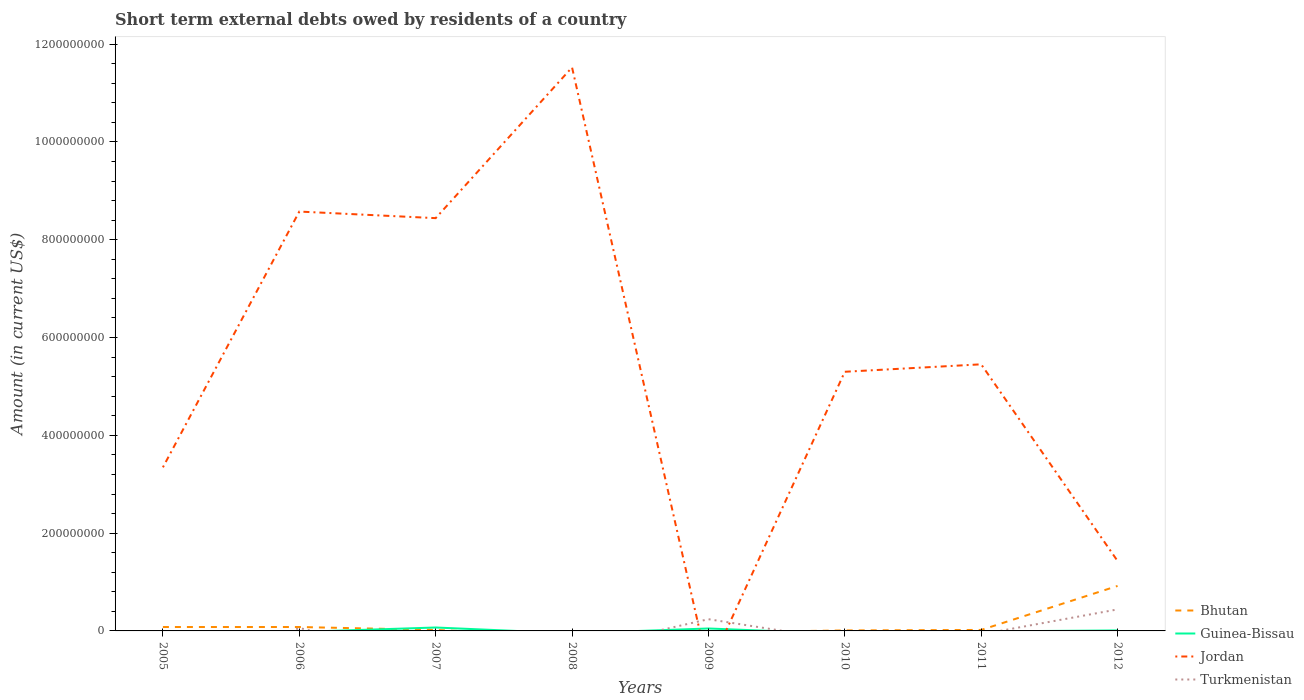How many different coloured lines are there?
Ensure brevity in your answer.  4. Does the line corresponding to Turkmenistan intersect with the line corresponding to Guinea-Bissau?
Give a very brief answer. Yes. What is the total amount of short-term external debts owed by residents in Turkmenistan in the graph?
Offer a very short reply. -1.80e+07. What is the difference between the highest and the second highest amount of short-term external debts owed by residents in Guinea-Bissau?
Make the answer very short. 7.00e+06. Is the amount of short-term external debts owed by residents in Guinea-Bissau strictly greater than the amount of short-term external debts owed by residents in Turkmenistan over the years?
Ensure brevity in your answer.  No. Are the values on the major ticks of Y-axis written in scientific E-notation?
Your answer should be compact. No. How are the legend labels stacked?
Your answer should be compact. Vertical. What is the title of the graph?
Offer a terse response. Short term external debts owed by residents of a country. What is the label or title of the X-axis?
Give a very brief answer. Years. What is the Amount (in current US$) of Bhutan in 2005?
Provide a short and direct response. 8.00e+06. What is the Amount (in current US$) in Jordan in 2005?
Your answer should be very brief. 3.35e+08. What is the Amount (in current US$) of Turkmenistan in 2005?
Provide a succinct answer. 0. What is the Amount (in current US$) of Guinea-Bissau in 2006?
Ensure brevity in your answer.  0. What is the Amount (in current US$) in Jordan in 2006?
Keep it short and to the point. 8.58e+08. What is the Amount (in current US$) of Guinea-Bissau in 2007?
Provide a succinct answer. 7.00e+06. What is the Amount (in current US$) in Jordan in 2007?
Provide a short and direct response. 8.44e+08. What is the Amount (in current US$) of Bhutan in 2008?
Your answer should be compact. 0. What is the Amount (in current US$) of Guinea-Bissau in 2008?
Keep it short and to the point. 0. What is the Amount (in current US$) of Jordan in 2008?
Make the answer very short. 1.15e+09. What is the Amount (in current US$) of Jordan in 2009?
Your answer should be very brief. 0. What is the Amount (in current US$) in Turkmenistan in 2009?
Your answer should be very brief. 2.40e+07. What is the Amount (in current US$) of Guinea-Bissau in 2010?
Your answer should be compact. 0. What is the Amount (in current US$) of Jordan in 2010?
Provide a short and direct response. 5.30e+08. What is the Amount (in current US$) in Turkmenistan in 2010?
Keep it short and to the point. 0. What is the Amount (in current US$) in Bhutan in 2011?
Provide a short and direct response. 2.00e+06. What is the Amount (in current US$) in Jordan in 2011?
Your response must be concise. 5.45e+08. What is the Amount (in current US$) in Turkmenistan in 2011?
Offer a very short reply. 0. What is the Amount (in current US$) of Bhutan in 2012?
Provide a succinct answer. 9.20e+07. What is the Amount (in current US$) in Jordan in 2012?
Provide a succinct answer. 1.43e+08. What is the Amount (in current US$) of Turkmenistan in 2012?
Ensure brevity in your answer.  4.40e+07. Across all years, what is the maximum Amount (in current US$) in Bhutan?
Keep it short and to the point. 9.20e+07. Across all years, what is the maximum Amount (in current US$) of Guinea-Bissau?
Ensure brevity in your answer.  7.00e+06. Across all years, what is the maximum Amount (in current US$) of Jordan?
Offer a very short reply. 1.15e+09. Across all years, what is the maximum Amount (in current US$) in Turkmenistan?
Your response must be concise. 4.40e+07. Across all years, what is the minimum Amount (in current US$) in Bhutan?
Your answer should be very brief. 0. Across all years, what is the minimum Amount (in current US$) of Guinea-Bissau?
Make the answer very short. 0. Across all years, what is the minimum Amount (in current US$) of Turkmenistan?
Keep it short and to the point. 0. What is the total Amount (in current US$) of Bhutan in the graph?
Keep it short and to the point. 1.13e+08. What is the total Amount (in current US$) of Guinea-Bissau in the graph?
Your response must be concise. 1.30e+07. What is the total Amount (in current US$) in Jordan in the graph?
Your answer should be very brief. 4.41e+09. What is the total Amount (in current US$) of Turkmenistan in the graph?
Your answer should be compact. 7.40e+07. What is the difference between the Amount (in current US$) in Jordan in 2005 and that in 2006?
Ensure brevity in your answer.  -5.23e+08. What is the difference between the Amount (in current US$) in Jordan in 2005 and that in 2007?
Your answer should be very brief. -5.10e+08. What is the difference between the Amount (in current US$) of Jordan in 2005 and that in 2008?
Make the answer very short. -8.18e+08. What is the difference between the Amount (in current US$) in Jordan in 2005 and that in 2010?
Give a very brief answer. -1.95e+08. What is the difference between the Amount (in current US$) in Bhutan in 2005 and that in 2011?
Offer a very short reply. 6.00e+06. What is the difference between the Amount (in current US$) in Jordan in 2005 and that in 2011?
Provide a succinct answer. -2.11e+08. What is the difference between the Amount (in current US$) in Bhutan in 2005 and that in 2012?
Your answer should be very brief. -8.40e+07. What is the difference between the Amount (in current US$) of Jordan in 2005 and that in 2012?
Offer a terse response. 1.91e+08. What is the difference between the Amount (in current US$) in Jordan in 2006 and that in 2007?
Ensure brevity in your answer.  1.35e+07. What is the difference between the Amount (in current US$) of Jordan in 2006 and that in 2008?
Provide a short and direct response. -2.95e+08. What is the difference between the Amount (in current US$) of Turkmenistan in 2006 and that in 2009?
Keep it short and to the point. -1.80e+07. What is the difference between the Amount (in current US$) in Jordan in 2006 and that in 2010?
Ensure brevity in your answer.  3.28e+08. What is the difference between the Amount (in current US$) in Bhutan in 2006 and that in 2011?
Offer a very short reply. 6.00e+06. What is the difference between the Amount (in current US$) of Jordan in 2006 and that in 2011?
Provide a succinct answer. 3.12e+08. What is the difference between the Amount (in current US$) of Bhutan in 2006 and that in 2012?
Your answer should be compact. -8.40e+07. What is the difference between the Amount (in current US$) in Jordan in 2006 and that in 2012?
Provide a succinct answer. 7.15e+08. What is the difference between the Amount (in current US$) of Turkmenistan in 2006 and that in 2012?
Your answer should be compact. -3.80e+07. What is the difference between the Amount (in current US$) in Jordan in 2007 and that in 2008?
Offer a terse response. -3.08e+08. What is the difference between the Amount (in current US$) in Jordan in 2007 and that in 2010?
Make the answer very short. 3.14e+08. What is the difference between the Amount (in current US$) of Bhutan in 2007 and that in 2011?
Ensure brevity in your answer.  0. What is the difference between the Amount (in current US$) of Jordan in 2007 and that in 2011?
Your response must be concise. 2.99e+08. What is the difference between the Amount (in current US$) in Bhutan in 2007 and that in 2012?
Your response must be concise. -9.00e+07. What is the difference between the Amount (in current US$) in Guinea-Bissau in 2007 and that in 2012?
Ensure brevity in your answer.  6.00e+06. What is the difference between the Amount (in current US$) of Jordan in 2007 and that in 2012?
Make the answer very short. 7.01e+08. What is the difference between the Amount (in current US$) in Jordan in 2008 and that in 2010?
Make the answer very short. 6.22e+08. What is the difference between the Amount (in current US$) in Jordan in 2008 and that in 2011?
Ensure brevity in your answer.  6.07e+08. What is the difference between the Amount (in current US$) of Jordan in 2008 and that in 2012?
Provide a short and direct response. 1.01e+09. What is the difference between the Amount (in current US$) in Turkmenistan in 2009 and that in 2012?
Your response must be concise. -2.00e+07. What is the difference between the Amount (in current US$) in Bhutan in 2010 and that in 2011?
Provide a succinct answer. -1.00e+06. What is the difference between the Amount (in current US$) in Jordan in 2010 and that in 2011?
Your answer should be very brief. -1.52e+07. What is the difference between the Amount (in current US$) of Bhutan in 2010 and that in 2012?
Offer a terse response. -9.10e+07. What is the difference between the Amount (in current US$) of Jordan in 2010 and that in 2012?
Provide a short and direct response. 3.87e+08. What is the difference between the Amount (in current US$) of Bhutan in 2011 and that in 2012?
Make the answer very short. -9.00e+07. What is the difference between the Amount (in current US$) in Jordan in 2011 and that in 2012?
Give a very brief answer. 4.02e+08. What is the difference between the Amount (in current US$) in Bhutan in 2005 and the Amount (in current US$) in Jordan in 2006?
Offer a terse response. -8.50e+08. What is the difference between the Amount (in current US$) of Bhutan in 2005 and the Amount (in current US$) of Turkmenistan in 2006?
Your answer should be very brief. 2.00e+06. What is the difference between the Amount (in current US$) in Jordan in 2005 and the Amount (in current US$) in Turkmenistan in 2006?
Make the answer very short. 3.29e+08. What is the difference between the Amount (in current US$) of Bhutan in 2005 and the Amount (in current US$) of Guinea-Bissau in 2007?
Ensure brevity in your answer.  1.00e+06. What is the difference between the Amount (in current US$) in Bhutan in 2005 and the Amount (in current US$) in Jordan in 2007?
Your response must be concise. -8.36e+08. What is the difference between the Amount (in current US$) of Bhutan in 2005 and the Amount (in current US$) of Jordan in 2008?
Provide a succinct answer. -1.14e+09. What is the difference between the Amount (in current US$) in Bhutan in 2005 and the Amount (in current US$) in Guinea-Bissau in 2009?
Your answer should be compact. 3.00e+06. What is the difference between the Amount (in current US$) of Bhutan in 2005 and the Amount (in current US$) of Turkmenistan in 2009?
Make the answer very short. -1.60e+07. What is the difference between the Amount (in current US$) of Jordan in 2005 and the Amount (in current US$) of Turkmenistan in 2009?
Offer a terse response. 3.11e+08. What is the difference between the Amount (in current US$) of Bhutan in 2005 and the Amount (in current US$) of Jordan in 2010?
Your answer should be compact. -5.22e+08. What is the difference between the Amount (in current US$) in Bhutan in 2005 and the Amount (in current US$) in Jordan in 2011?
Your response must be concise. -5.37e+08. What is the difference between the Amount (in current US$) in Bhutan in 2005 and the Amount (in current US$) in Guinea-Bissau in 2012?
Ensure brevity in your answer.  7.00e+06. What is the difference between the Amount (in current US$) in Bhutan in 2005 and the Amount (in current US$) in Jordan in 2012?
Your answer should be compact. -1.35e+08. What is the difference between the Amount (in current US$) of Bhutan in 2005 and the Amount (in current US$) of Turkmenistan in 2012?
Your response must be concise. -3.60e+07. What is the difference between the Amount (in current US$) in Jordan in 2005 and the Amount (in current US$) in Turkmenistan in 2012?
Provide a short and direct response. 2.91e+08. What is the difference between the Amount (in current US$) of Bhutan in 2006 and the Amount (in current US$) of Guinea-Bissau in 2007?
Provide a succinct answer. 1.00e+06. What is the difference between the Amount (in current US$) of Bhutan in 2006 and the Amount (in current US$) of Jordan in 2007?
Your response must be concise. -8.36e+08. What is the difference between the Amount (in current US$) of Bhutan in 2006 and the Amount (in current US$) of Jordan in 2008?
Make the answer very short. -1.14e+09. What is the difference between the Amount (in current US$) in Bhutan in 2006 and the Amount (in current US$) in Guinea-Bissau in 2009?
Offer a very short reply. 3.00e+06. What is the difference between the Amount (in current US$) in Bhutan in 2006 and the Amount (in current US$) in Turkmenistan in 2009?
Give a very brief answer. -1.60e+07. What is the difference between the Amount (in current US$) of Jordan in 2006 and the Amount (in current US$) of Turkmenistan in 2009?
Offer a terse response. 8.34e+08. What is the difference between the Amount (in current US$) of Bhutan in 2006 and the Amount (in current US$) of Jordan in 2010?
Provide a short and direct response. -5.22e+08. What is the difference between the Amount (in current US$) of Bhutan in 2006 and the Amount (in current US$) of Jordan in 2011?
Your answer should be very brief. -5.37e+08. What is the difference between the Amount (in current US$) of Bhutan in 2006 and the Amount (in current US$) of Guinea-Bissau in 2012?
Ensure brevity in your answer.  7.00e+06. What is the difference between the Amount (in current US$) in Bhutan in 2006 and the Amount (in current US$) in Jordan in 2012?
Provide a succinct answer. -1.35e+08. What is the difference between the Amount (in current US$) of Bhutan in 2006 and the Amount (in current US$) of Turkmenistan in 2012?
Offer a terse response. -3.60e+07. What is the difference between the Amount (in current US$) of Jordan in 2006 and the Amount (in current US$) of Turkmenistan in 2012?
Your answer should be very brief. 8.14e+08. What is the difference between the Amount (in current US$) in Bhutan in 2007 and the Amount (in current US$) in Jordan in 2008?
Make the answer very short. -1.15e+09. What is the difference between the Amount (in current US$) of Guinea-Bissau in 2007 and the Amount (in current US$) of Jordan in 2008?
Give a very brief answer. -1.15e+09. What is the difference between the Amount (in current US$) in Bhutan in 2007 and the Amount (in current US$) in Turkmenistan in 2009?
Provide a succinct answer. -2.20e+07. What is the difference between the Amount (in current US$) in Guinea-Bissau in 2007 and the Amount (in current US$) in Turkmenistan in 2009?
Provide a succinct answer. -1.70e+07. What is the difference between the Amount (in current US$) in Jordan in 2007 and the Amount (in current US$) in Turkmenistan in 2009?
Your answer should be very brief. 8.20e+08. What is the difference between the Amount (in current US$) of Bhutan in 2007 and the Amount (in current US$) of Jordan in 2010?
Your answer should be very brief. -5.28e+08. What is the difference between the Amount (in current US$) in Guinea-Bissau in 2007 and the Amount (in current US$) in Jordan in 2010?
Provide a succinct answer. -5.23e+08. What is the difference between the Amount (in current US$) of Bhutan in 2007 and the Amount (in current US$) of Jordan in 2011?
Provide a succinct answer. -5.43e+08. What is the difference between the Amount (in current US$) in Guinea-Bissau in 2007 and the Amount (in current US$) in Jordan in 2011?
Make the answer very short. -5.38e+08. What is the difference between the Amount (in current US$) in Bhutan in 2007 and the Amount (in current US$) in Jordan in 2012?
Provide a short and direct response. -1.41e+08. What is the difference between the Amount (in current US$) of Bhutan in 2007 and the Amount (in current US$) of Turkmenistan in 2012?
Your response must be concise. -4.20e+07. What is the difference between the Amount (in current US$) in Guinea-Bissau in 2007 and the Amount (in current US$) in Jordan in 2012?
Provide a short and direct response. -1.36e+08. What is the difference between the Amount (in current US$) of Guinea-Bissau in 2007 and the Amount (in current US$) of Turkmenistan in 2012?
Your answer should be compact. -3.70e+07. What is the difference between the Amount (in current US$) of Jordan in 2007 and the Amount (in current US$) of Turkmenistan in 2012?
Ensure brevity in your answer.  8.00e+08. What is the difference between the Amount (in current US$) of Jordan in 2008 and the Amount (in current US$) of Turkmenistan in 2009?
Ensure brevity in your answer.  1.13e+09. What is the difference between the Amount (in current US$) of Jordan in 2008 and the Amount (in current US$) of Turkmenistan in 2012?
Give a very brief answer. 1.11e+09. What is the difference between the Amount (in current US$) of Guinea-Bissau in 2009 and the Amount (in current US$) of Jordan in 2010?
Keep it short and to the point. -5.25e+08. What is the difference between the Amount (in current US$) of Guinea-Bissau in 2009 and the Amount (in current US$) of Jordan in 2011?
Provide a short and direct response. -5.40e+08. What is the difference between the Amount (in current US$) of Guinea-Bissau in 2009 and the Amount (in current US$) of Jordan in 2012?
Offer a terse response. -1.38e+08. What is the difference between the Amount (in current US$) of Guinea-Bissau in 2009 and the Amount (in current US$) of Turkmenistan in 2012?
Make the answer very short. -3.90e+07. What is the difference between the Amount (in current US$) in Bhutan in 2010 and the Amount (in current US$) in Jordan in 2011?
Provide a short and direct response. -5.44e+08. What is the difference between the Amount (in current US$) in Bhutan in 2010 and the Amount (in current US$) in Guinea-Bissau in 2012?
Ensure brevity in your answer.  0. What is the difference between the Amount (in current US$) of Bhutan in 2010 and the Amount (in current US$) of Jordan in 2012?
Make the answer very short. -1.42e+08. What is the difference between the Amount (in current US$) in Bhutan in 2010 and the Amount (in current US$) in Turkmenistan in 2012?
Provide a short and direct response. -4.30e+07. What is the difference between the Amount (in current US$) in Jordan in 2010 and the Amount (in current US$) in Turkmenistan in 2012?
Offer a terse response. 4.86e+08. What is the difference between the Amount (in current US$) of Bhutan in 2011 and the Amount (in current US$) of Jordan in 2012?
Give a very brief answer. -1.41e+08. What is the difference between the Amount (in current US$) of Bhutan in 2011 and the Amount (in current US$) of Turkmenistan in 2012?
Your answer should be very brief. -4.20e+07. What is the difference between the Amount (in current US$) of Jordan in 2011 and the Amount (in current US$) of Turkmenistan in 2012?
Your answer should be compact. 5.01e+08. What is the average Amount (in current US$) in Bhutan per year?
Your answer should be compact. 1.41e+07. What is the average Amount (in current US$) of Guinea-Bissau per year?
Keep it short and to the point. 1.62e+06. What is the average Amount (in current US$) of Jordan per year?
Your response must be concise. 5.51e+08. What is the average Amount (in current US$) in Turkmenistan per year?
Ensure brevity in your answer.  9.25e+06. In the year 2005, what is the difference between the Amount (in current US$) in Bhutan and Amount (in current US$) in Jordan?
Your response must be concise. -3.27e+08. In the year 2006, what is the difference between the Amount (in current US$) of Bhutan and Amount (in current US$) of Jordan?
Your response must be concise. -8.50e+08. In the year 2006, what is the difference between the Amount (in current US$) of Jordan and Amount (in current US$) of Turkmenistan?
Provide a short and direct response. 8.52e+08. In the year 2007, what is the difference between the Amount (in current US$) of Bhutan and Amount (in current US$) of Guinea-Bissau?
Give a very brief answer. -5.00e+06. In the year 2007, what is the difference between the Amount (in current US$) of Bhutan and Amount (in current US$) of Jordan?
Ensure brevity in your answer.  -8.42e+08. In the year 2007, what is the difference between the Amount (in current US$) of Guinea-Bissau and Amount (in current US$) of Jordan?
Make the answer very short. -8.37e+08. In the year 2009, what is the difference between the Amount (in current US$) in Guinea-Bissau and Amount (in current US$) in Turkmenistan?
Provide a short and direct response. -1.90e+07. In the year 2010, what is the difference between the Amount (in current US$) of Bhutan and Amount (in current US$) of Jordan?
Provide a succinct answer. -5.29e+08. In the year 2011, what is the difference between the Amount (in current US$) in Bhutan and Amount (in current US$) in Jordan?
Your response must be concise. -5.43e+08. In the year 2012, what is the difference between the Amount (in current US$) in Bhutan and Amount (in current US$) in Guinea-Bissau?
Give a very brief answer. 9.10e+07. In the year 2012, what is the difference between the Amount (in current US$) of Bhutan and Amount (in current US$) of Jordan?
Keep it short and to the point. -5.11e+07. In the year 2012, what is the difference between the Amount (in current US$) of Bhutan and Amount (in current US$) of Turkmenistan?
Offer a very short reply. 4.80e+07. In the year 2012, what is the difference between the Amount (in current US$) in Guinea-Bissau and Amount (in current US$) in Jordan?
Your response must be concise. -1.42e+08. In the year 2012, what is the difference between the Amount (in current US$) in Guinea-Bissau and Amount (in current US$) in Turkmenistan?
Keep it short and to the point. -4.30e+07. In the year 2012, what is the difference between the Amount (in current US$) in Jordan and Amount (in current US$) in Turkmenistan?
Your answer should be very brief. 9.91e+07. What is the ratio of the Amount (in current US$) in Jordan in 2005 to that in 2006?
Provide a short and direct response. 0.39. What is the ratio of the Amount (in current US$) in Jordan in 2005 to that in 2007?
Your response must be concise. 0.4. What is the ratio of the Amount (in current US$) of Jordan in 2005 to that in 2008?
Your answer should be very brief. 0.29. What is the ratio of the Amount (in current US$) in Bhutan in 2005 to that in 2010?
Keep it short and to the point. 8. What is the ratio of the Amount (in current US$) of Jordan in 2005 to that in 2010?
Provide a succinct answer. 0.63. What is the ratio of the Amount (in current US$) of Bhutan in 2005 to that in 2011?
Offer a terse response. 4. What is the ratio of the Amount (in current US$) in Jordan in 2005 to that in 2011?
Your answer should be compact. 0.61. What is the ratio of the Amount (in current US$) in Bhutan in 2005 to that in 2012?
Keep it short and to the point. 0.09. What is the ratio of the Amount (in current US$) of Jordan in 2005 to that in 2012?
Keep it short and to the point. 2.34. What is the ratio of the Amount (in current US$) of Jordan in 2006 to that in 2007?
Keep it short and to the point. 1.02. What is the ratio of the Amount (in current US$) of Jordan in 2006 to that in 2008?
Provide a succinct answer. 0.74. What is the ratio of the Amount (in current US$) of Turkmenistan in 2006 to that in 2009?
Offer a terse response. 0.25. What is the ratio of the Amount (in current US$) of Bhutan in 2006 to that in 2010?
Offer a terse response. 8. What is the ratio of the Amount (in current US$) in Jordan in 2006 to that in 2010?
Keep it short and to the point. 1.62. What is the ratio of the Amount (in current US$) in Jordan in 2006 to that in 2011?
Give a very brief answer. 1.57. What is the ratio of the Amount (in current US$) in Bhutan in 2006 to that in 2012?
Provide a succinct answer. 0.09. What is the ratio of the Amount (in current US$) of Jordan in 2006 to that in 2012?
Your answer should be very brief. 5.99. What is the ratio of the Amount (in current US$) in Turkmenistan in 2006 to that in 2012?
Make the answer very short. 0.14. What is the ratio of the Amount (in current US$) in Jordan in 2007 to that in 2008?
Provide a succinct answer. 0.73. What is the ratio of the Amount (in current US$) in Guinea-Bissau in 2007 to that in 2009?
Provide a succinct answer. 1.4. What is the ratio of the Amount (in current US$) of Jordan in 2007 to that in 2010?
Offer a terse response. 1.59. What is the ratio of the Amount (in current US$) of Bhutan in 2007 to that in 2011?
Your response must be concise. 1. What is the ratio of the Amount (in current US$) of Jordan in 2007 to that in 2011?
Your answer should be very brief. 1.55. What is the ratio of the Amount (in current US$) of Bhutan in 2007 to that in 2012?
Your response must be concise. 0.02. What is the ratio of the Amount (in current US$) of Guinea-Bissau in 2007 to that in 2012?
Keep it short and to the point. 7. What is the ratio of the Amount (in current US$) of Jordan in 2007 to that in 2012?
Your answer should be very brief. 5.9. What is the ratio of the Amount (in current US$) in Jordan in 2008 to that in 2010?
Ensure brevity in your answer.  2.17. What is the ratio of the Amount (in current US$) in Jordan in 2008 to that in 2011?
Keep it short and to the point. 2.11. What is the ratio of the Amount (in current US$) in Jordan in 2008 to that in 2012?
Give a very brief answer. 8.05. What is the ratio of the Amount (in current US$) of Turkmenistan in 2009 to that in 2012?
Provide a succinct answer. 0.55. What is the ratio of the Amount (in current US$) of Bhutan in 2010 to that in 2011?
Provide a short and direct response. 0.5. What is the ratio of the Amount (in current US$) in Jordan in 2010 to that in 2011?
Make the answer very short. 0.97. What is the ratio of the Amount (in current US$) of Bhutan in 2010 to that in 2012?
Offer a very short reply. 0.01. What is the ratio of the Amount (in current US$) in Jordan in 2010 to that in 2012?
Offer a terse response. 3.7. What is the ratio of the Amount (in current US$) of Bhutan in 2011 to that in 2012?
Provide a short and direct response. 0.02. What is the ratio of the Amount (in current US$) in Jordan in 2011 to that in 2012?
Keep it short and to the point. 3.81. What is the difference between the highest and the second highest Amount (in current US$) of Bhutan?
Keep it short and to the point. 8.40e+07. What is the difference between the highest and the second highest Amount (in current US$) in Guinea-Bissau?
Offer a very short reply. 2.00e+06. What is the difference between the highest and the second highest Amount (in current US$) of Jordan?
Your answer should be very brief. 2.95e+08. What is the difference between the highest and the lowest Amount (in current US$) in Bhutan?
Your response must be concise. 9.20e+07. What is the difference between the highest and the lowest Amount (in current US$) of Jordan?
Ensure brevity in your answer.  1.15e+09. What is the difference between the highest and the lowest Amount (in current US$) in Turkmenistan?
Your answer should be very brief. 4.40e+07. 